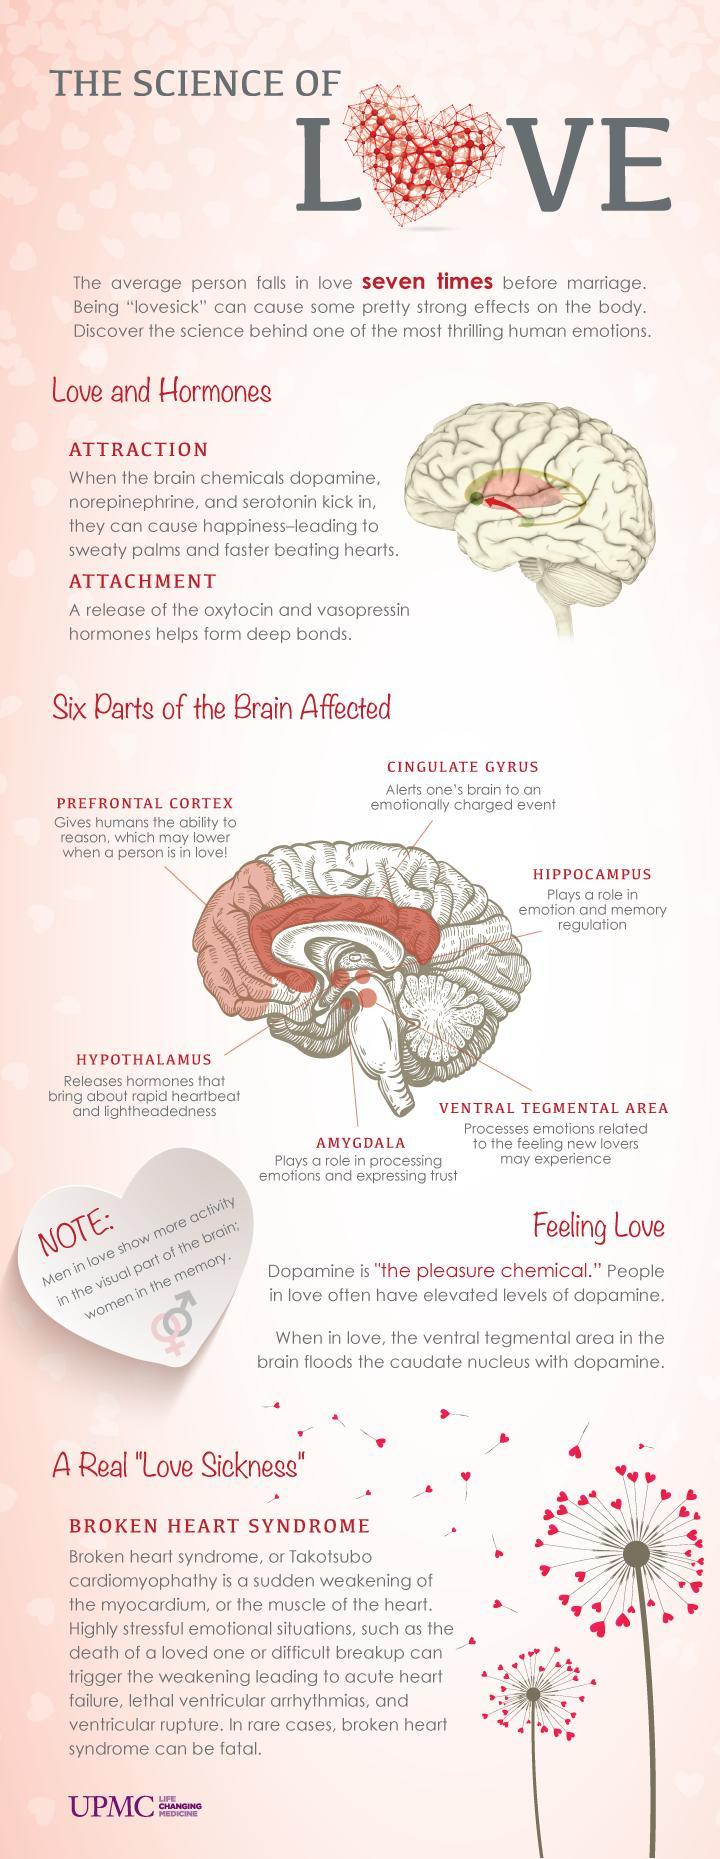What are the points under the heading "Love and Hormones"?
Answer the question with a short phrase. Attraction, Attachment How many points are under the heading "Love and Hormones"? 2 Which part of the brain plays a role in processing emotions and expressing trust? Amygdala Which part of the brain processes emotions related to the feeling new lovers may experience? Ventral Tegmental Area 